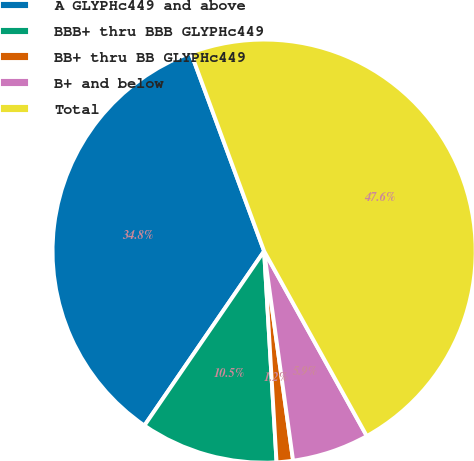<chart> <loc_0><loc_0><loc_500><loc_500><pie_chart><fcel>A GLYPHc449 and above<fcel>BBB+ thru BBB GLYPHc449<fcel>BB+ thru BB GLYPHc449<fcel>B+ and below<fcel>Total<nl><fcel>34.8%<fcel>10.51%<fcel>1.25%<fcel>5.88%<fcel>47.56%<nl></chart> 